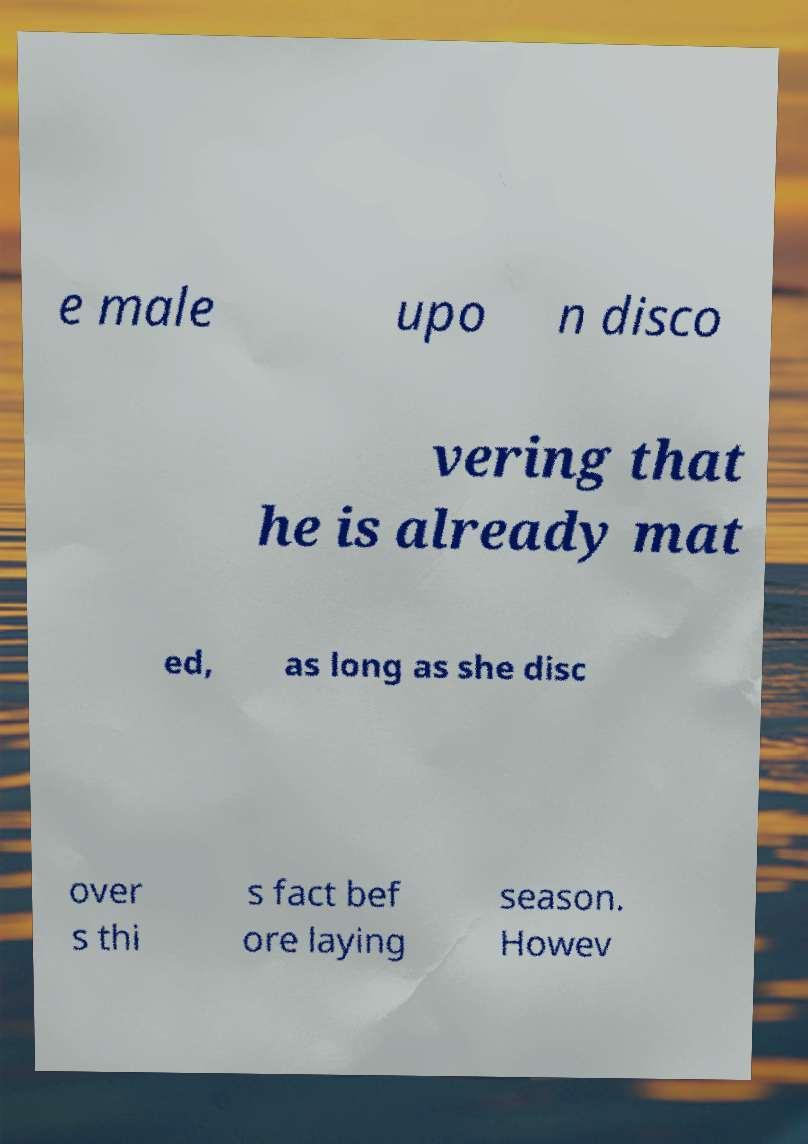Please read and relay the text visible in this image. What does it say? e male upo n disco vering that he is already mat ed, as long as she disc over s thi s fact bef ore laying season. Howev 